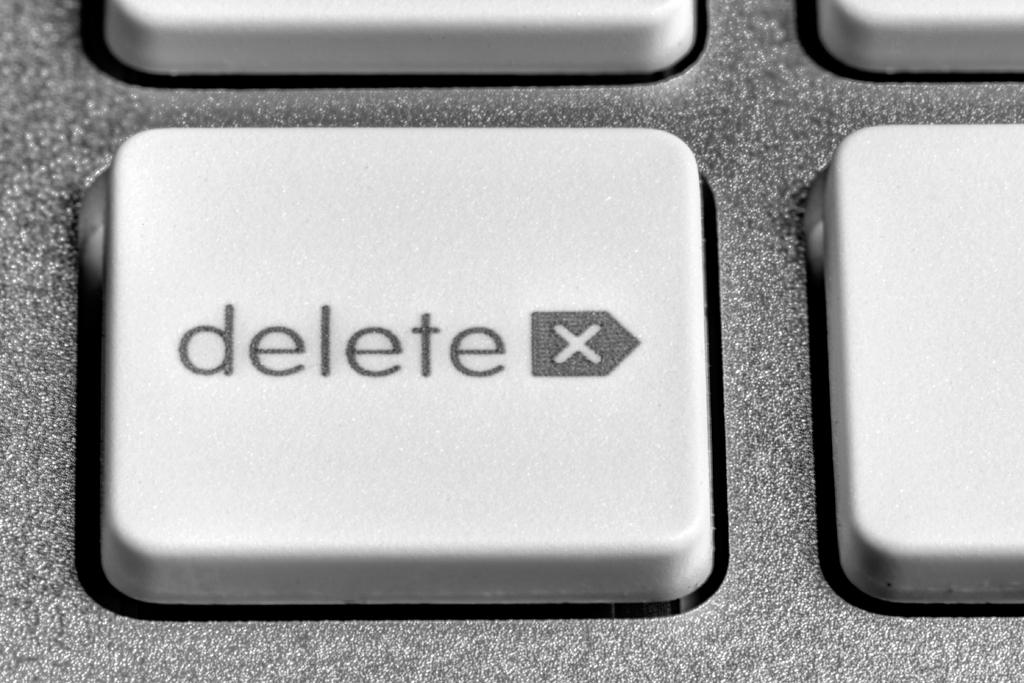<image>
Describe the image concisely. A delete key with an x on it is shown. 